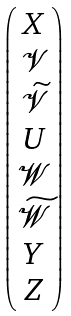<formula> <loc_0><loc_0><loc_500><loc_500>\begin{pmatrix} X \\ \mathcal { V } \\ \widetilde { \mathcal { V } } \\ U \\ \mathcal { W } \\ \widetilde { \mathcal { W } } \\ Y \\ Z \end{pmatrix}</formula> 